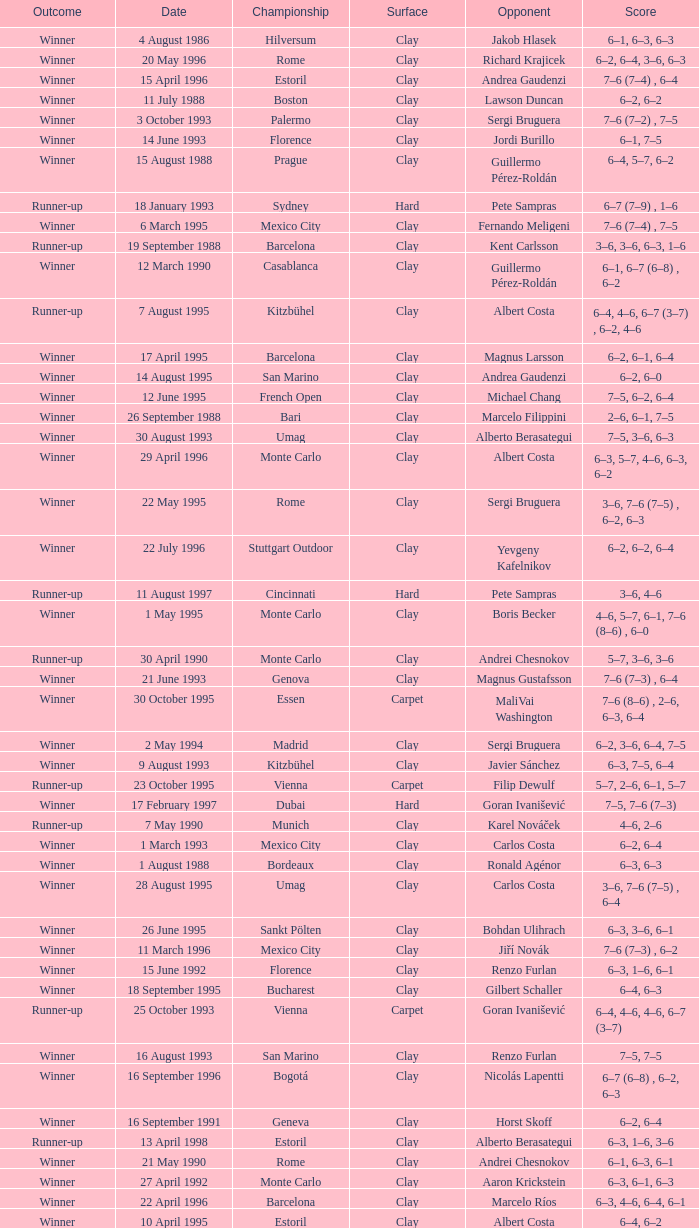Who is the opponent on 18 january 1993? Pete Sampras. 